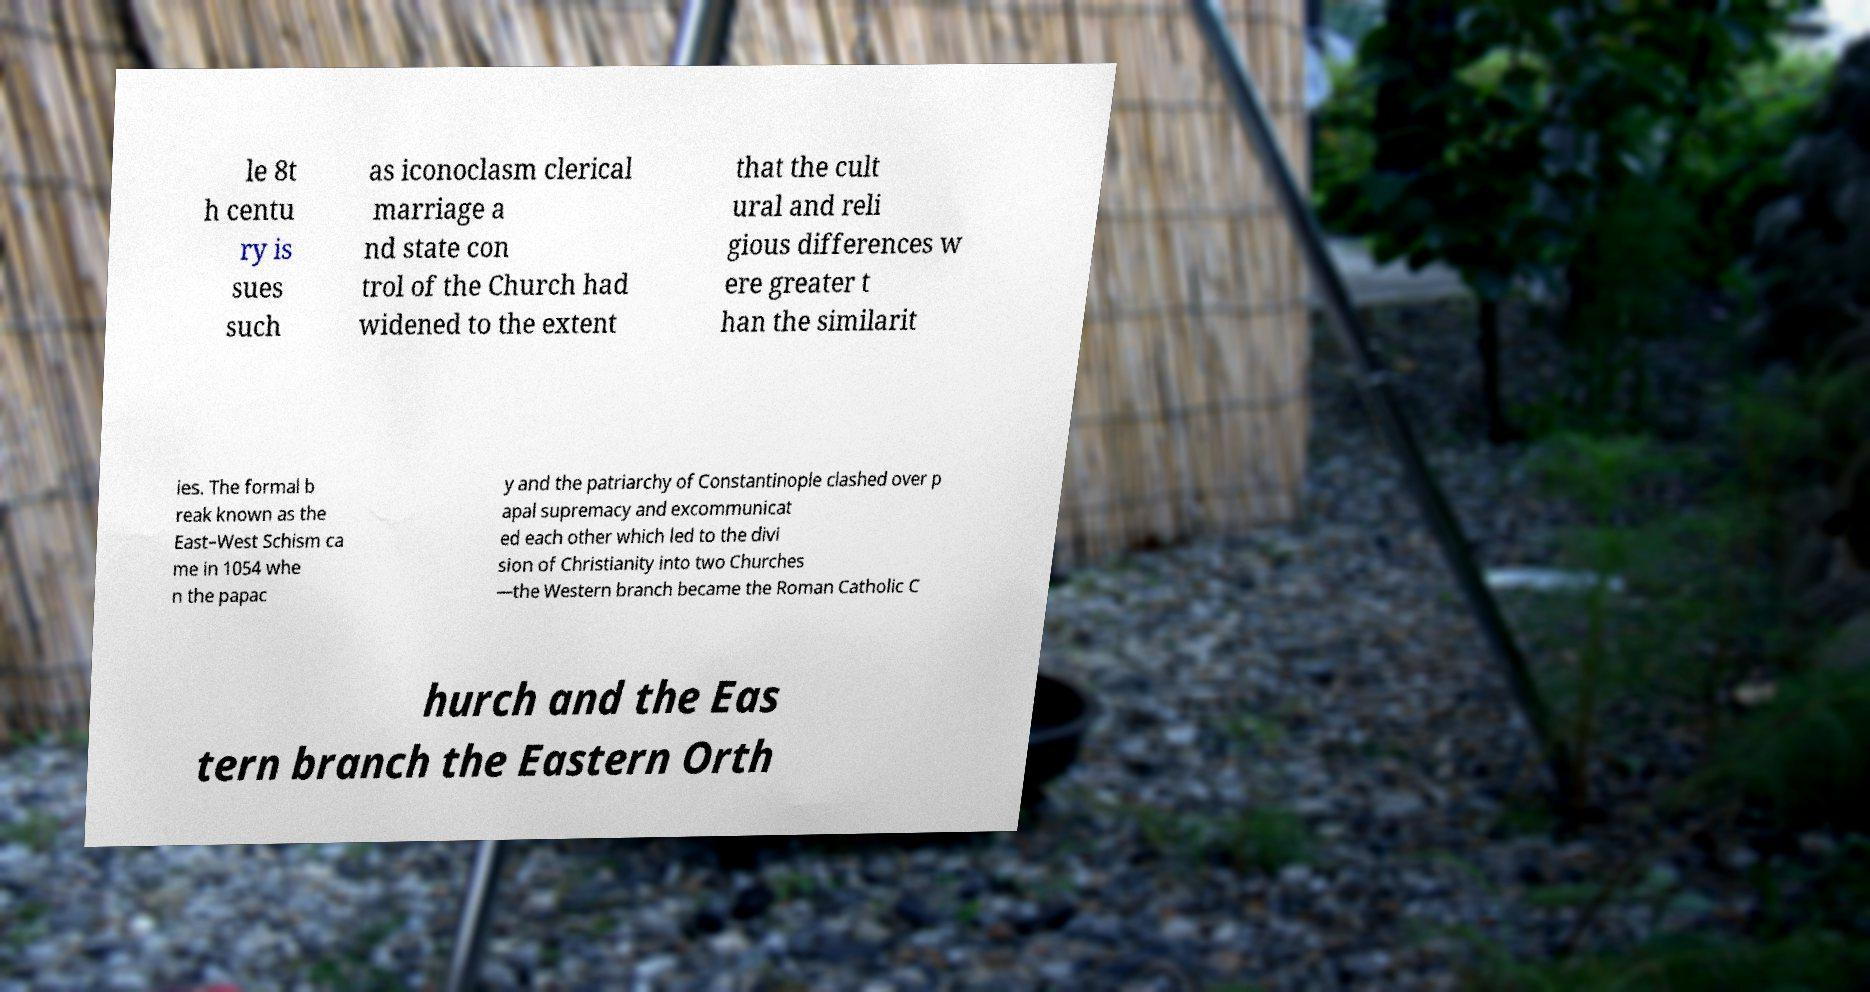I need the written content from this picture converted into text. Can you do that? le 8t h centu ry is sues such as iconoclasm clerical marriage a nd state con trol of the Church had widened to the extent that the cult ural and reli gious differences w ere greater t han the similarit ies. The formal b reak known as the East–West Schism ca me in 1054 whe n the papac y and the patriarchy of Constantinople clashed over p apal supremacy and excommunicat ed each other which led to the divi sion of Christianity into two Churches —the Western branch became the Roman Catholic C hurch and the Eas tern branch the Eastern Orth 